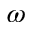<formula> <loc_0><loc_0><loc_500><loc_500>\omega</formula> 